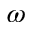<formula> <loc_0><loc_0><loc_500><loc_500>\omega</formula> 